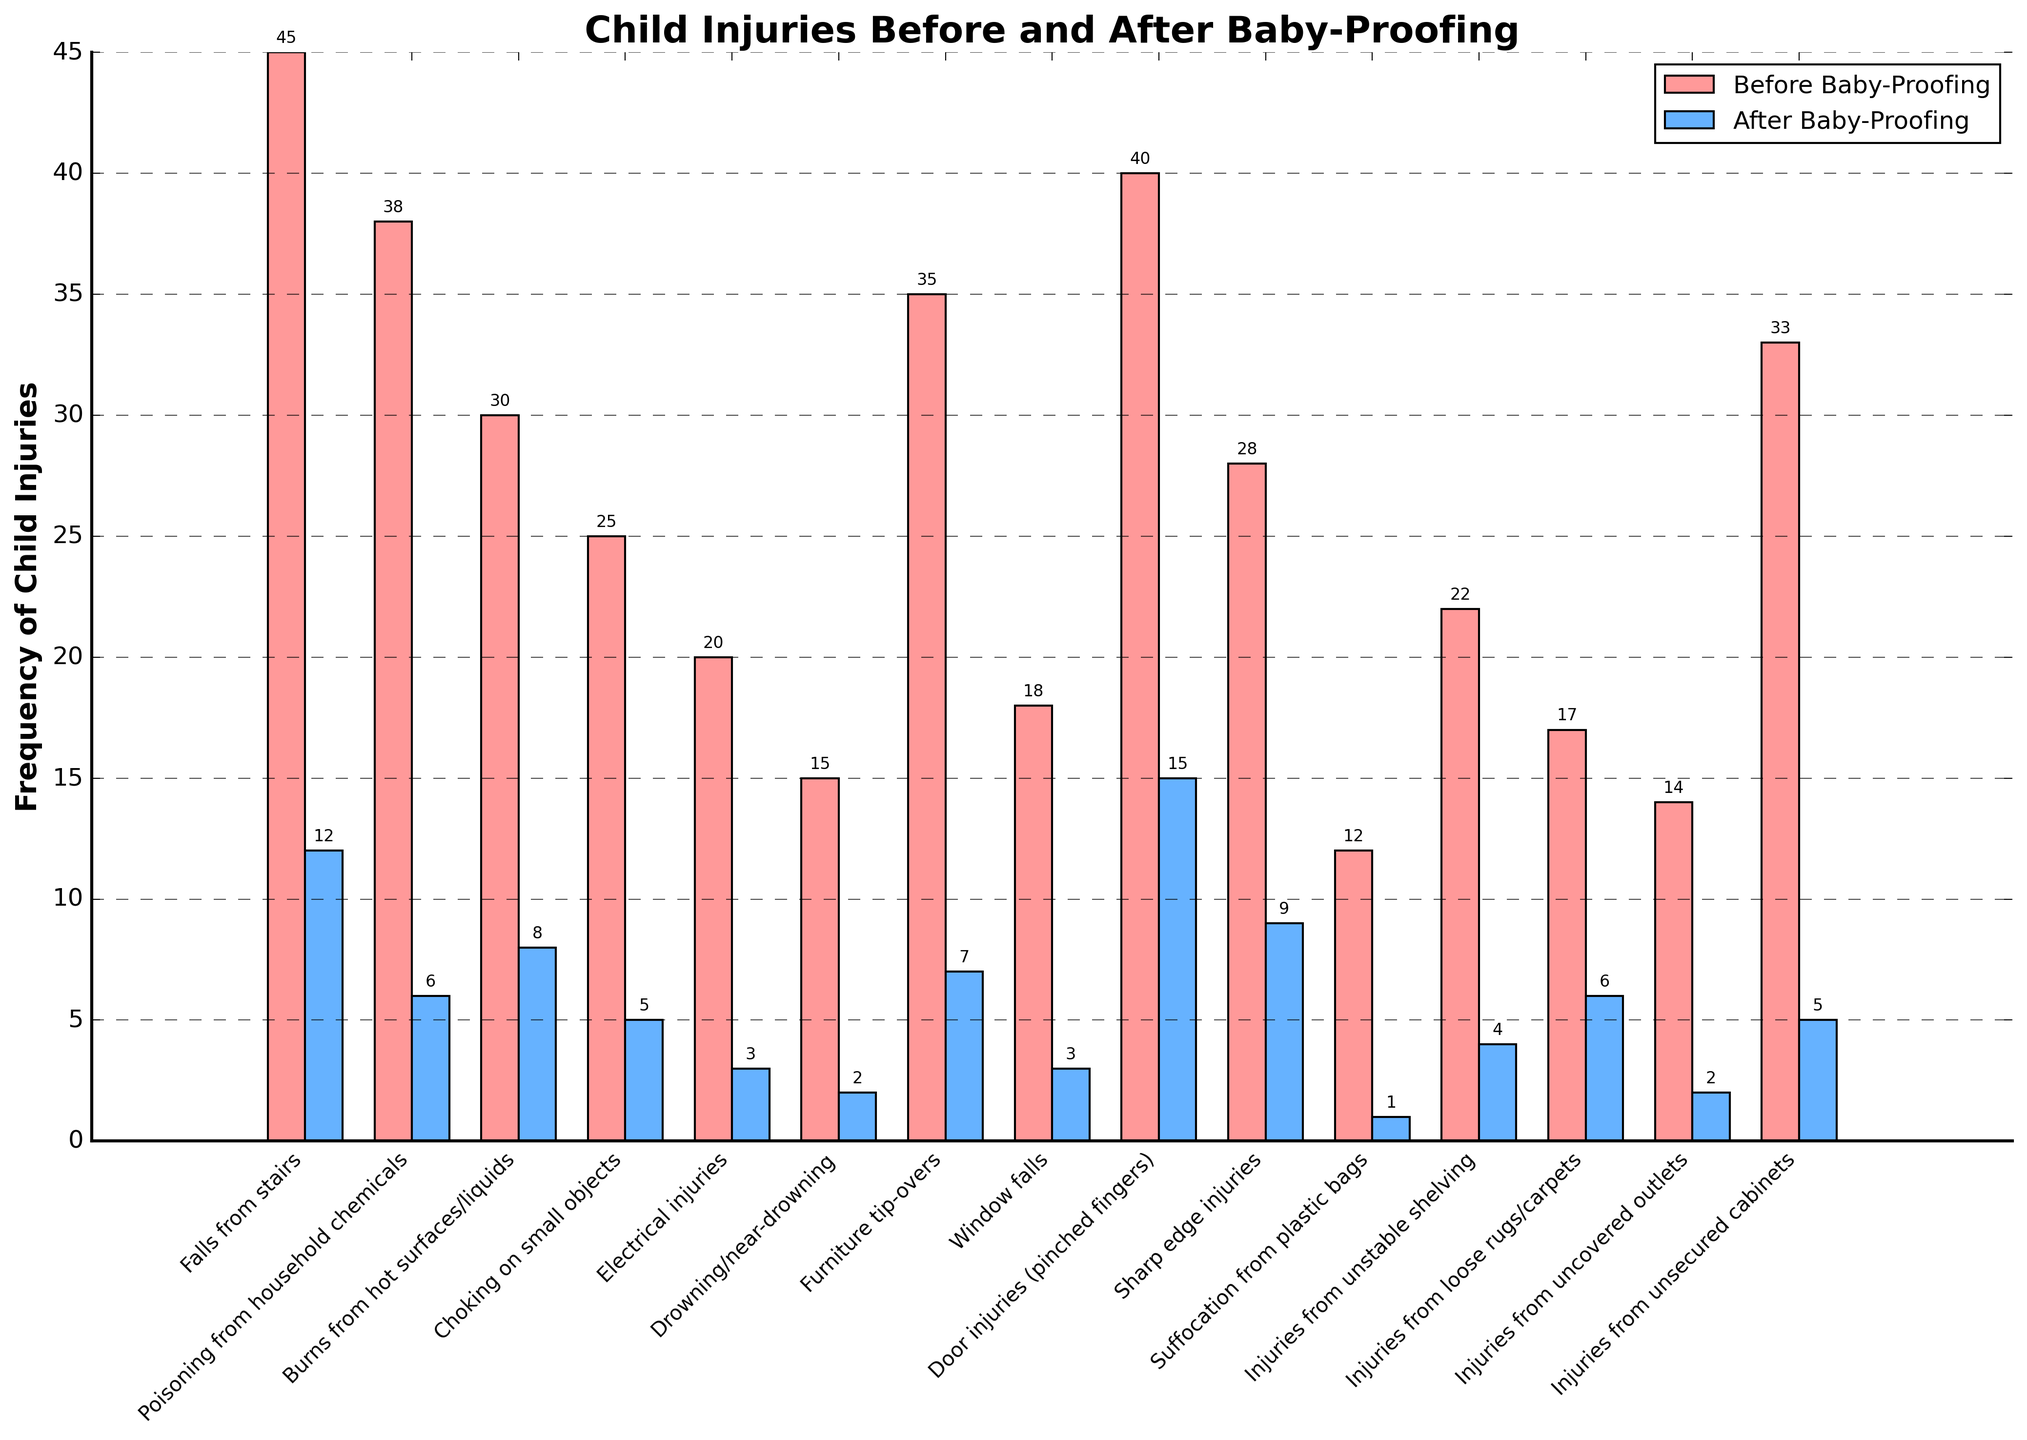what type of accident remains the most frequent after baby-proofing? Look at the highest bar in the "After Baby-Proofing" section. The highest frequency after baby-proofing is door injuries (pinched fingers).
Answer: Door injuries (pinched fingers) By what percentage did the frequency of poisoning from household chemicals decrease after baby-proofing? Calculate the decrease: 38 - 6 = 32. Calculate the percentage decrease: (32/38) * 100 ≈ 84.21%.
Answer: 84.21% Which type of accident experienced the largest reduction in frequency after baby-proofing? Compare the height differences between "Before" and "After" for all accident types. The largest reduction is for falls from stairs, which decreased by 33 incidents (45 - 12).
Answer: Falls from stairs Calculate the total number of child injuries before and after baby-proofing. Sum all frequencies for both "Before" and "After" categories. Before: 45+38+30+25+20+15+35+18+40+28+12+22+17+14+33 = 392. After: 12+6+8+5+3+2+7+3+15+9+1+4+6+2+5 = 88.
Answer: Before: 392, After: 88 Which type of accident had a greater frequency than 20 before baby-proofing but fell to 5 or less after baby-proofing? Identify all types with "Before" frequency > 20. Examine their corresponding "After" values. Electrical injuries, which decreased from 20 to 3, meets the condition.
Answer: Electrical injuries What is the average frequency of injuries from sharp edges before and after baby-proofing? (Before + After) / 2 = (28 + 9) / 2 = 18.5.
Answer: 18.5 Which accident type had a reduction of exactly 18 incidents? Calculate the reduction for each type. Suffocation from plastic bags: 12 - 1 = 11; Drowning/near-drowning: 15 - 2 = 13; Burns from hot surfaces/liquids: 30 - 8 = 22; Falls from stairs: 45 - 12 = 33; Furniture tip-overs: 35 - 7 = 28; Choking on small objects: 25 - 5 = 20; Door injuries (pinched fingers): 40 - 15 = 25; Window falls: 18 - 3 = 15; Sharp edge injuries: 28 - 9 = 19; Poisoning from household chemicals: 38 - 6 = 32; Electrical injuries: 20 - 3 = 17; Unstable shelving: 22 - 4 = 18. It's injuries from unstable shelving.
Answer: Injuries from unstable shelving By how much did the frequency of injuries from unsecured cabinets drop after baby-proofing? Subtract the "After" value from the "Before" value for injuries from unsecured cabinets. 33 - 5 = 28.
Answer: 28 Which accident had the smallest frequency before baby-proofing and how much did it decrease after baby-proofing? Look for the smallest value in the "Before Baby-Proofing" category and then find the difference with the corresponding "After" value. Suffocation from plastic bags had a frequency of 12 before, decreasing by 11 after baby-proofing.
Answer: Suffocation from plastic bags, decreased by 11 What is the decrease in the average frequency of all accident types after baby-proofing? Calculate the average before and after: Before: 392/15 ≈ 26.13, After: 88/15 ≈ 5.87. The decrease is: 26.13 - 5.87 ≈ 20.26.
Answer: ≈ 20.26 